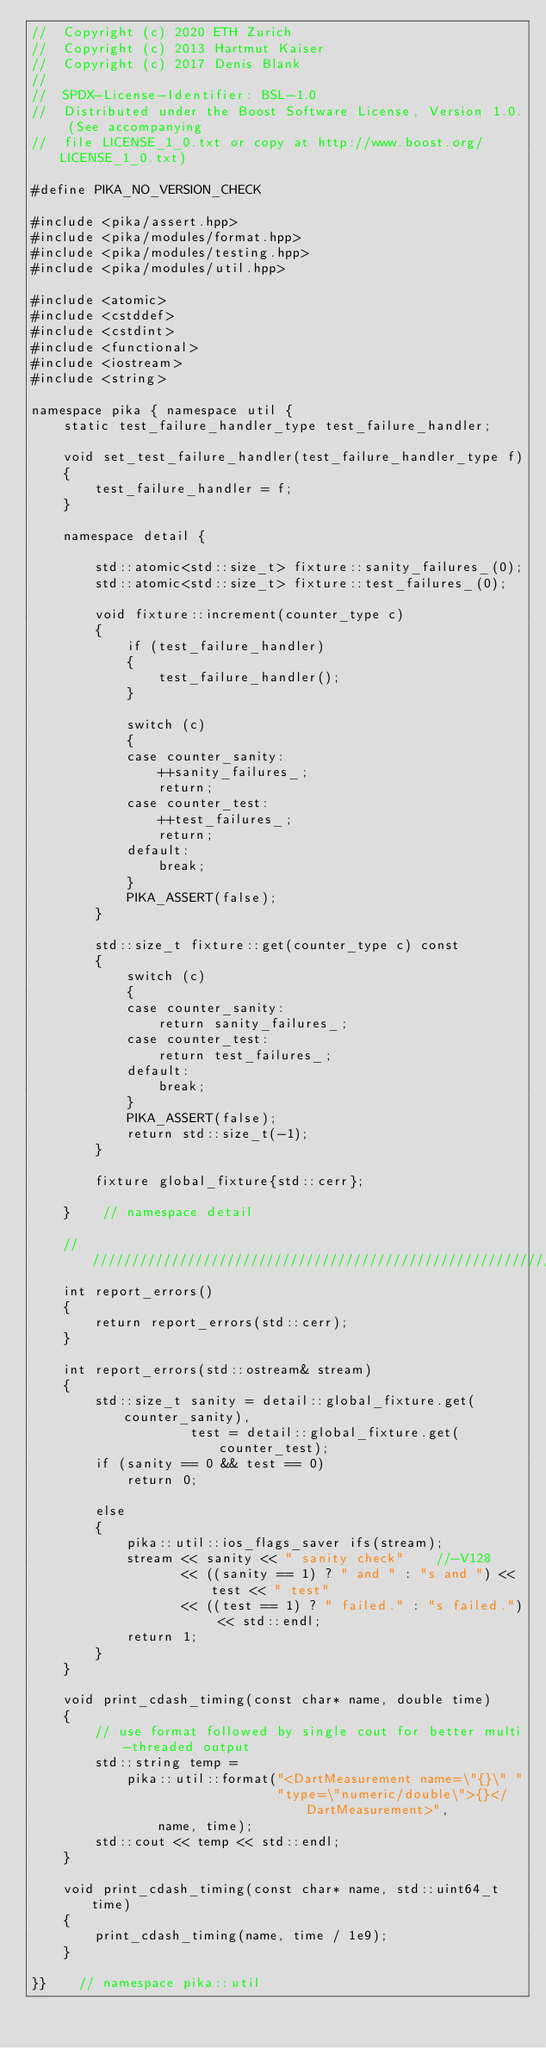<code> <loc_0><loc_0><loc_500><loc_500><_C++_>//  Copyright (c) 2020 ETH Zurich
//  Copyright (c) 2013 Hartmut Kaiser
//  Copyright (c) 2017 Denis Blank
//
//  SPDX-License-Identifier: BSL-1.0
//  Distributed under the Boost Software License, Version 1.0. (See accompanying
//  file LICENSE_1_0.txt or copy at http://www.boost.org/LICENSE_1_0.txt)

#define PIKA_NO_VERSION_CHECK

#include <pika/assert.hpp>
#include <pika/modules/format.hpp>
#include <pika/modules/testing.hpp>
#include <pika/modules/util.hpp>

#include <atomic>
#include <cstddef>
#include <cstdint>
#include <functional>
#include <iostream>
#include <string>

namespace pika { namespace util {
    static test_failure_handler_type test_failure_handler;

    void set_test_failure_handler(test_failure_handler_type f)
    {
        test_failure_handler = f;
    }

    namespace detail {

        std::atomic<std::size_t> fixture::sanity_failures_(0);
        std::atomic<std::size_t> fixture::test_failures_(0);

        void fixture::increment(counter_type c)
        {
            if (test_failure_handler)
            {
                test_failure_handler();
            }

            switch (c)
            {
            case counter_sanity:
                ++sanity_failures_;
                return;
            case counter_test:
                ++test_failures_;
                return;
            default:
                break;
            }
            PIKA_ASSERT(false);
        }

        std::size_t fixture::get(counter_type c) const
        {
            switch (c)
            {
            case counter_sanity:
                return sanity_failures_;
            case counter_test:
                return test_failures_;
            default:
                break;
            }
            PIKA_ASSERT(false);
            return std::size_t(-1);
        }

        fixture global_fixture{std::cerr};

    }    // namespace detail

    ////////////////////////////////////////////////////////////////////////////
    int report_errors()
    {
        return report_errors(std::cerr);
    }

    int report_errors(std::ostream& stream)
    {
        std::size_t sanity = detail::global_fixture.get(counter_sanity),
                    test = detail::global_fixture.get(counter_test);
        if (sanity == 0 && test == 0)
            return 0;

        else
        {
            pika::util::ios_flags_saver ifs(stream);
            stream << sanity << " sanity check"    //-V128
                   << ((sanity == 1) ? " and " : "s and ") << test << " test"
                   << ((test == 1) ? " failed." : "s failed.") << std::endl;
            return 1;
        }
    }

    void print_cdash_timing(const char* name, double time)
    {
        // use format followed by single cout for better multi-threaded output
        std::string temp =
            pika::util::format("<DartMeasurement name=\"{}\" "
                               "type=\"numeric/double\">{}</DartMeasurement>",
                name, time);
        std::cout << temp << std::endl;
    }

    void print_cdash_timing(const char* name, std::uint64_t time)
    {
        print_cdash_timing(name, time / 1e9);
    }

}}    // namespace pika::util
</code> 